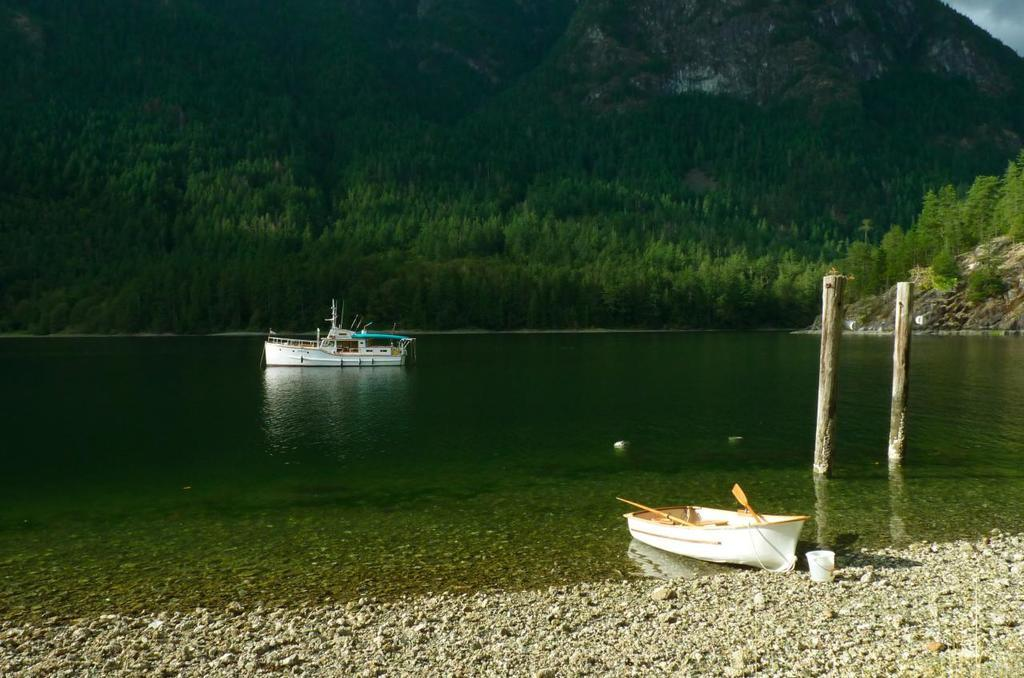What is on the water in the image? There are boats on the water in the image. What object can be seen near the water? There is a bucket in the image. What type of structures are present in the image? There are wooden poles in the image. What type of natural environment is visible in the image? There are trees and a mountain in the image. What type of news is being discussed in the lunchroom in the image? There is no lunchroom present in the image, and therefore no discussion of news can be observed. What color is the shirt worn by the person in the image? There is no person present in the image, and therefore no shirt can be observed. 